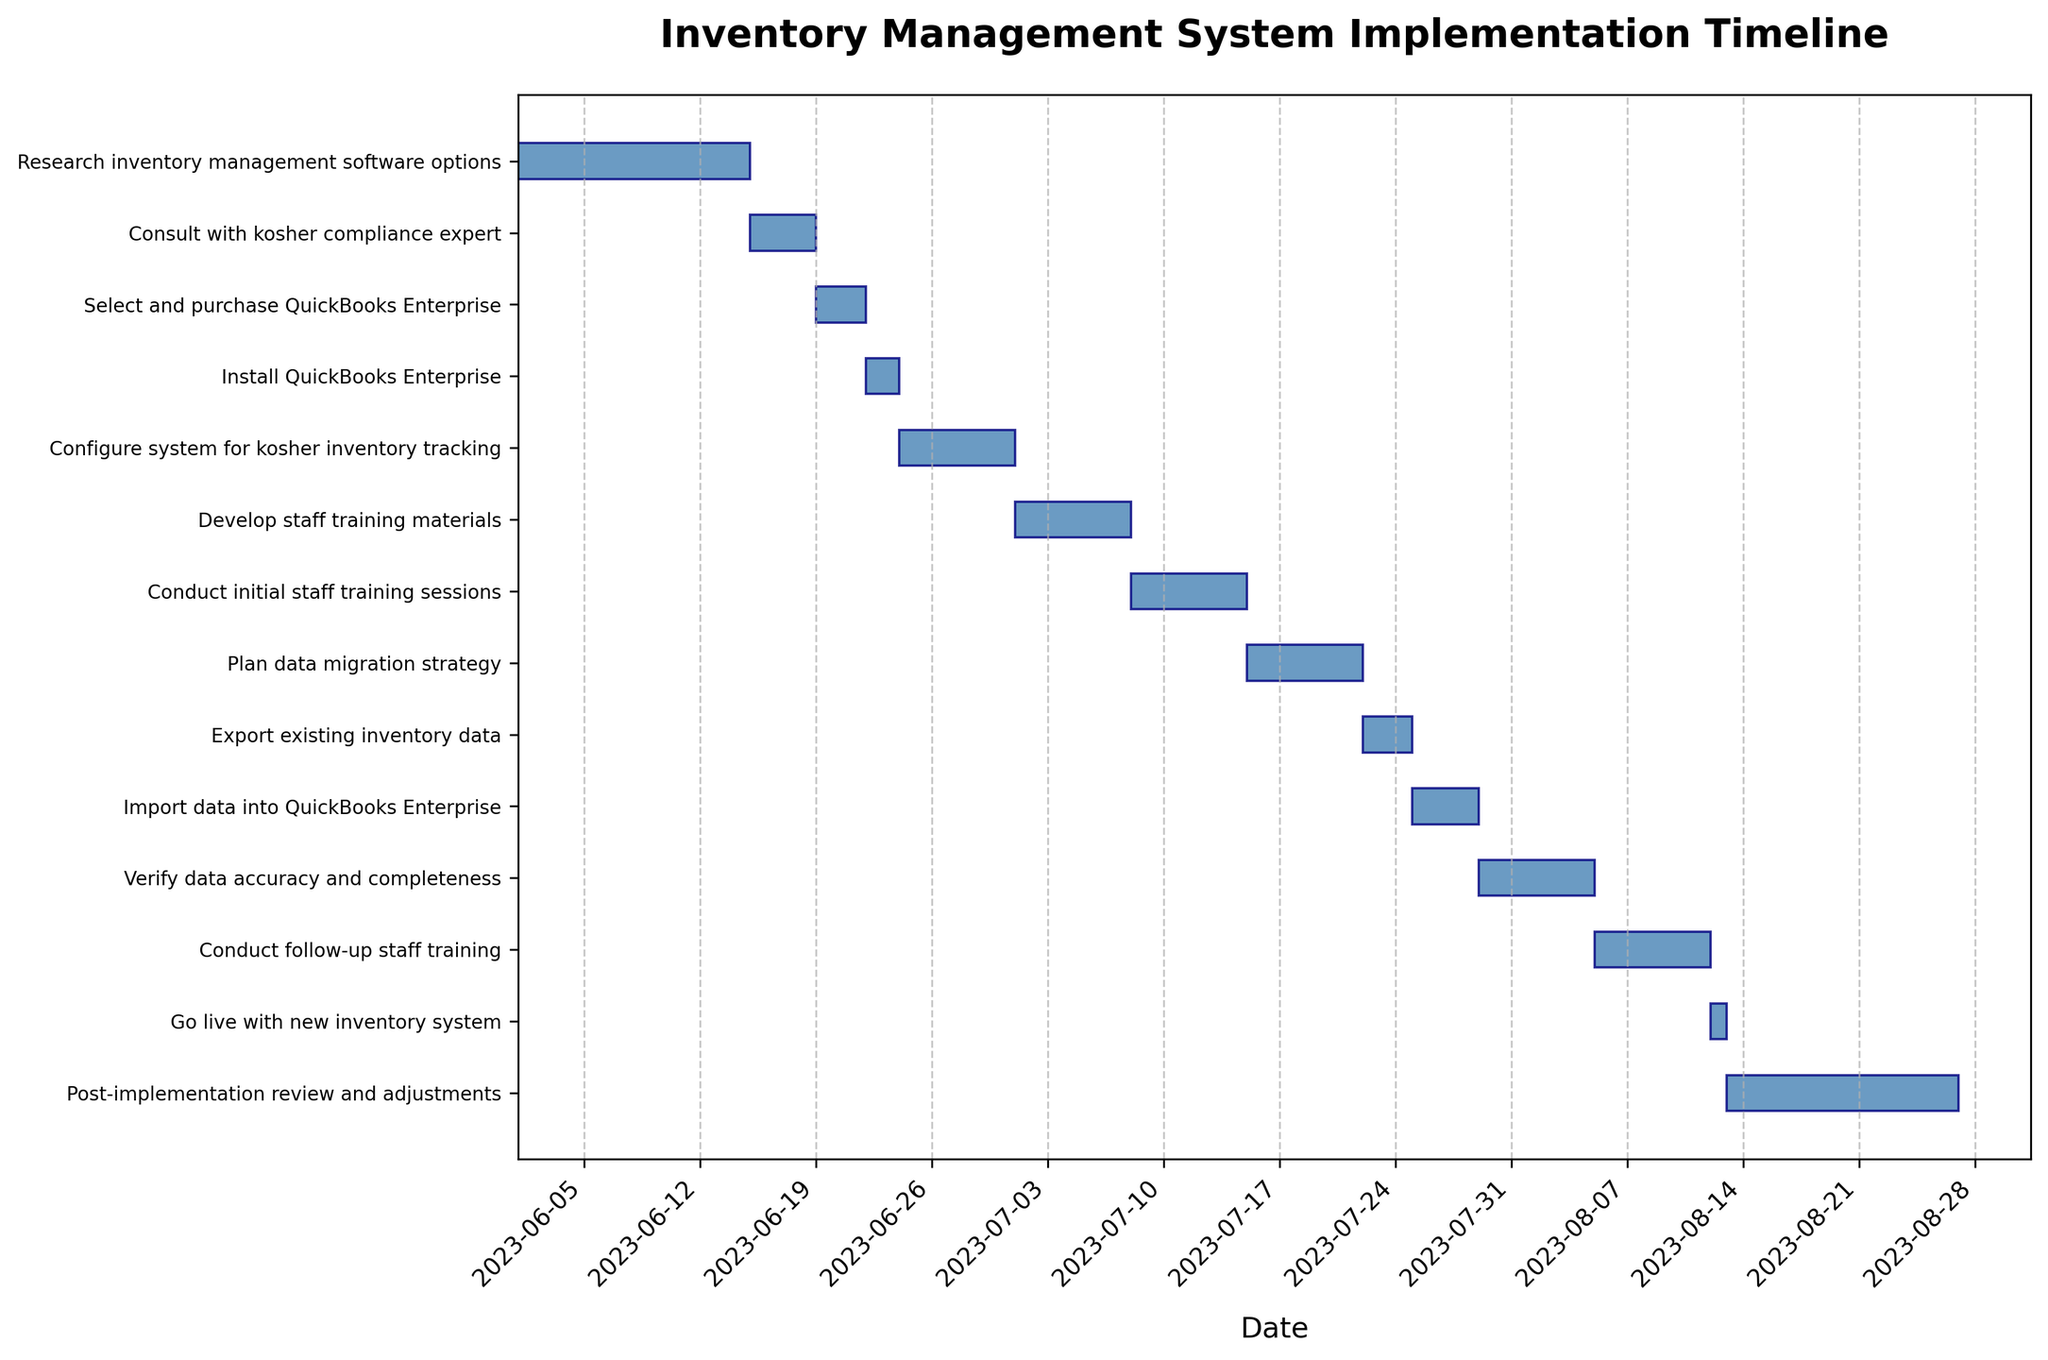Who donated the most to the rabbi’s charity last year? The figure shows the name and donation amount of the top donors to the rabbi’s charity last year. To determine who donated the most, look for the donor with the highest bar in the chart.
Answer: Donor A Which month had the highest donation total? The figure shows donation amounts on a monthly basis. Identify the month with the tallest bar, indicating the highest total donations.
Answer: December What is the total donation amount for the entire year? Add up the donation amounts from each month shown in the chart to get the total annual donation. Examine each bar and sum their values.
Answer: $100,000 How do donations in the summer months compare to winter months? To compare summer and winter donations, look at the bars representing June, July, and August (summer) and compare them to December, January, and February (winter). Assess which set of bars is taller overall.
Answer: Winter donations are higher What is the average donation amount per month? To find the average, sum all the monthly donations and divide by the number of months. Add up all the bars' heights and divide by 12.
Answer: $8,333.33 Which donor had the most consistent donation amount across different months? Consistent donations have bars of similar height. Look for a donor (bar color) where the bars are roughly equal height throughout the chart.
Answer: Donor C How many donors contributed to the charity in all 12 months? Look for donors who have a bar for each month in the chart. Count the number of distinct donors (colors) appearing every month.
Answer: 3 donors What was the least amount donated in a single month, and which donor made that donation? Identify the shortest bar in the chart and note its value and the associated donor color. The height of this bar represents the smallest donation.
Answer: $500 by Donor D 